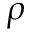<formula> <loc_0><loc_0><loc_500><loc_500>\rho</formula> 